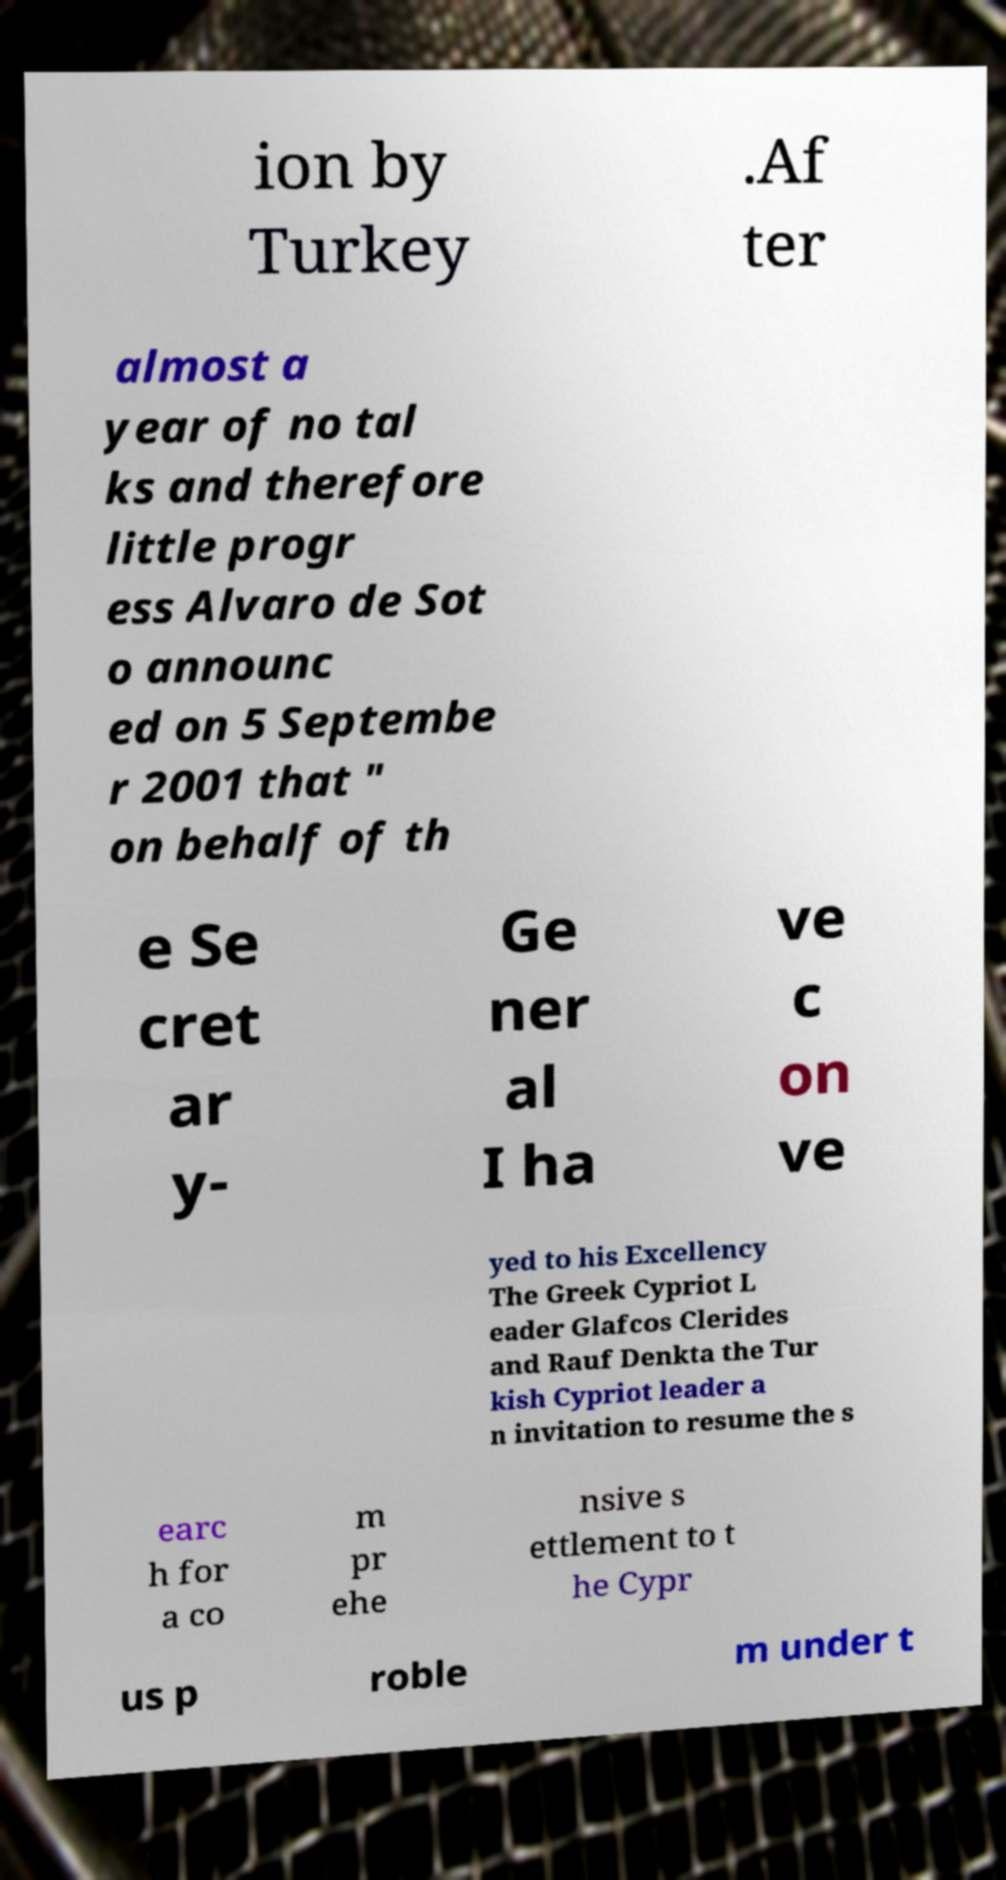Could you assist in decoding the text presented in this image and type it out clearly? ion by Turkey .Af ter almost a year of no tal ks and therefore little progr ess Alvaro de Sot o announc ed on 5 Septembe r 2001 that " on behalf of th e Se cret ar y- Ge ner al I ha ve c on ve yed to his Excellency The Greek Cypriot L eader Glafcos Clerides and Rauf Denkta the Tur kish Cypriot leader a n invitation to resume the s earc h for a co m pr ehe nsive s ettlement to t he Cypr us p roble m under t 